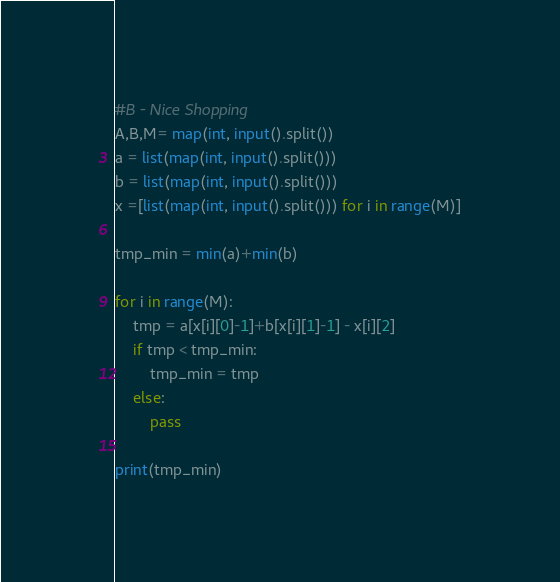Convert code to text. <code><loc_0><loc_0><loc_500><loc_500><_Python_>#B - Nice Shopping
A,B,M= map(int, input().split())
a = list(map(int, input().split()))
b = list(map(int, input().split()))
x =[list(map(int, input().split())) for i in range(M)]

tmp_min = min(a)+min(b)

for i in range(M):
    tmp = a[x[i][0]-1]+b[x[i][1]-1] - x[i][2]
    if tmp < tmp_min:
        tmp_min = tmp
    else:
        pass

print(tmp_min)</code> 